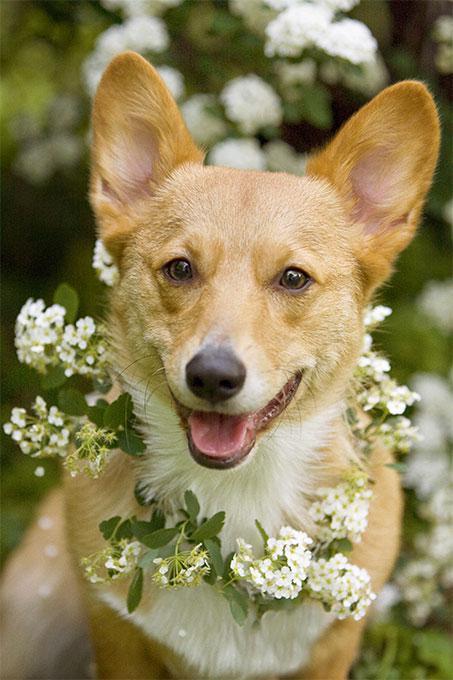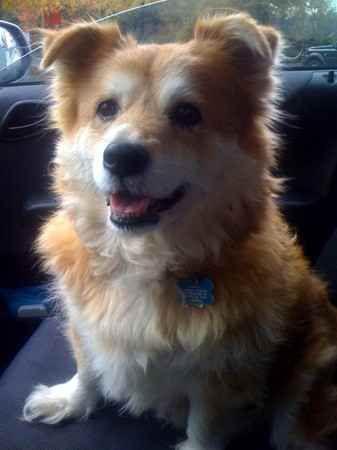The first image is the image on the left, the second image is the image on the right. For the images displayed, is the sentence "The dog in the right hand image stands on grass while the dog in the left hand image does not." factually correct? Answer yes or no. No. The first image is the image on the left, the second image is the image on the right. Evaluate the accuracy of this statement regarding the images: "An image shows one short-legged dog standing in profile on green grass, with its face turned to the camera.". Is it true? Answer yes or no. No. The first image is the image on the left, the second image is the image on the right. For the images shown, is this caption "There are two dogs and neither of them have any black fur." true? Answer yes or no. Yes. 